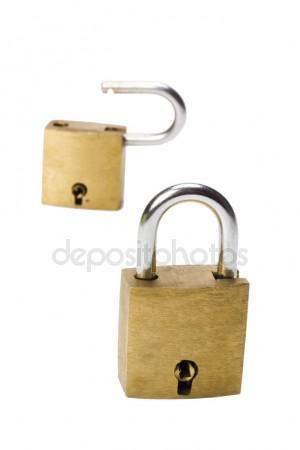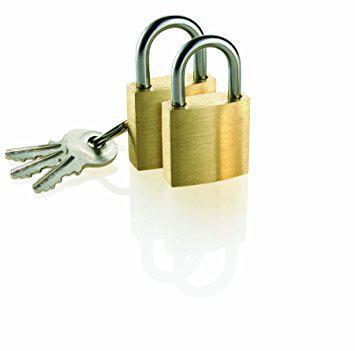The first image is the image on the left, the second image is the image on the right. Analyze the images presented: Is the assertion "An image shows a ring of keys next to, but not attached to, an upright lock." valid? Answer yes or no. Yes. The first image is the image on the left, the second image is the image on the right. For the images shown, is this caption "There's at least two keys in the right image." true? Answer yes or no. Yes. 